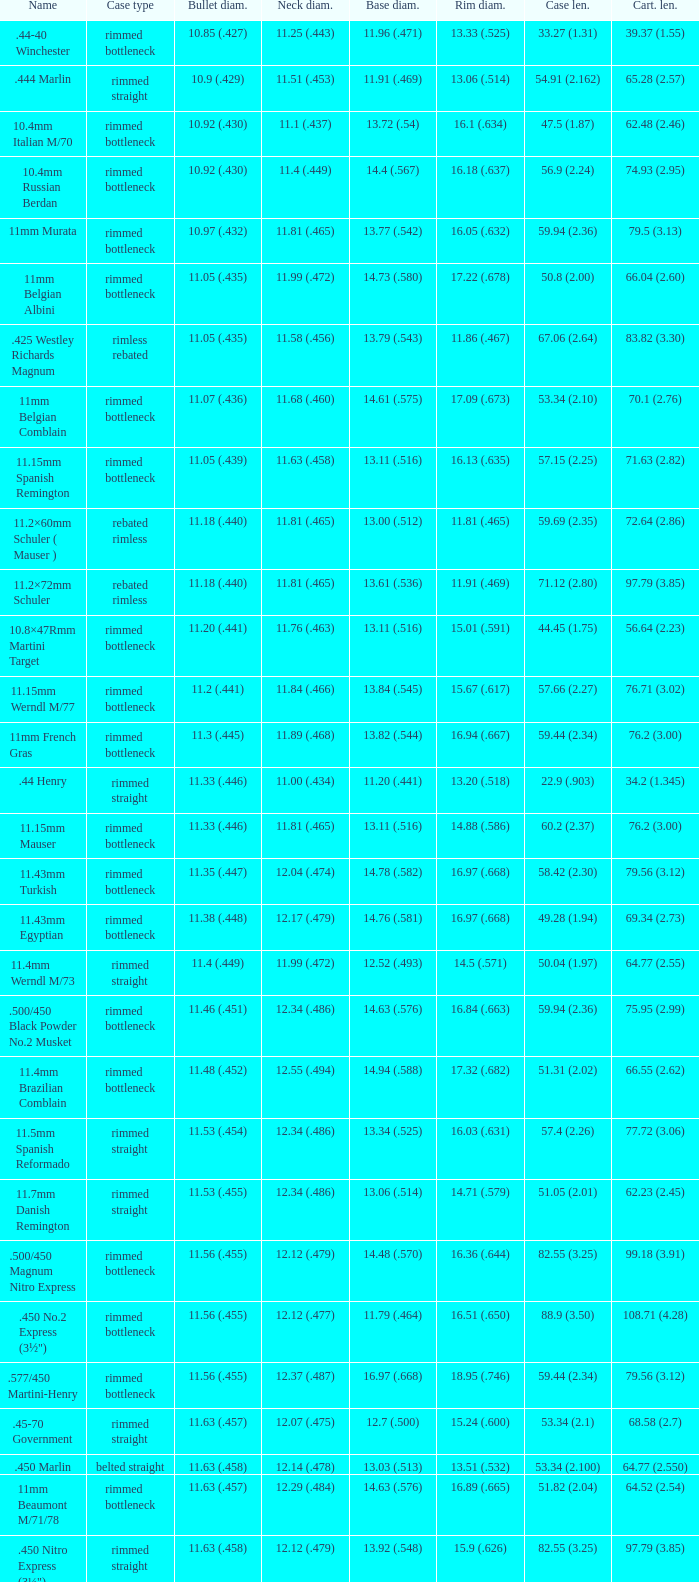Which Rim diameter has a Neck diameter of 11.84 (.466)? 15.67 (.617). 